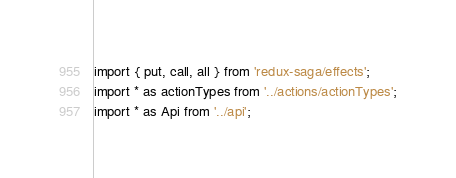Convert code to text. <code><loc_0><loc_0><loc_500><loc_500><_JavaScript_>import { put, call, all } from 'redux-saga/effects';
import * as actionTypes from '../actions/actionTypes';
import * as Api from '../api';
</code> 